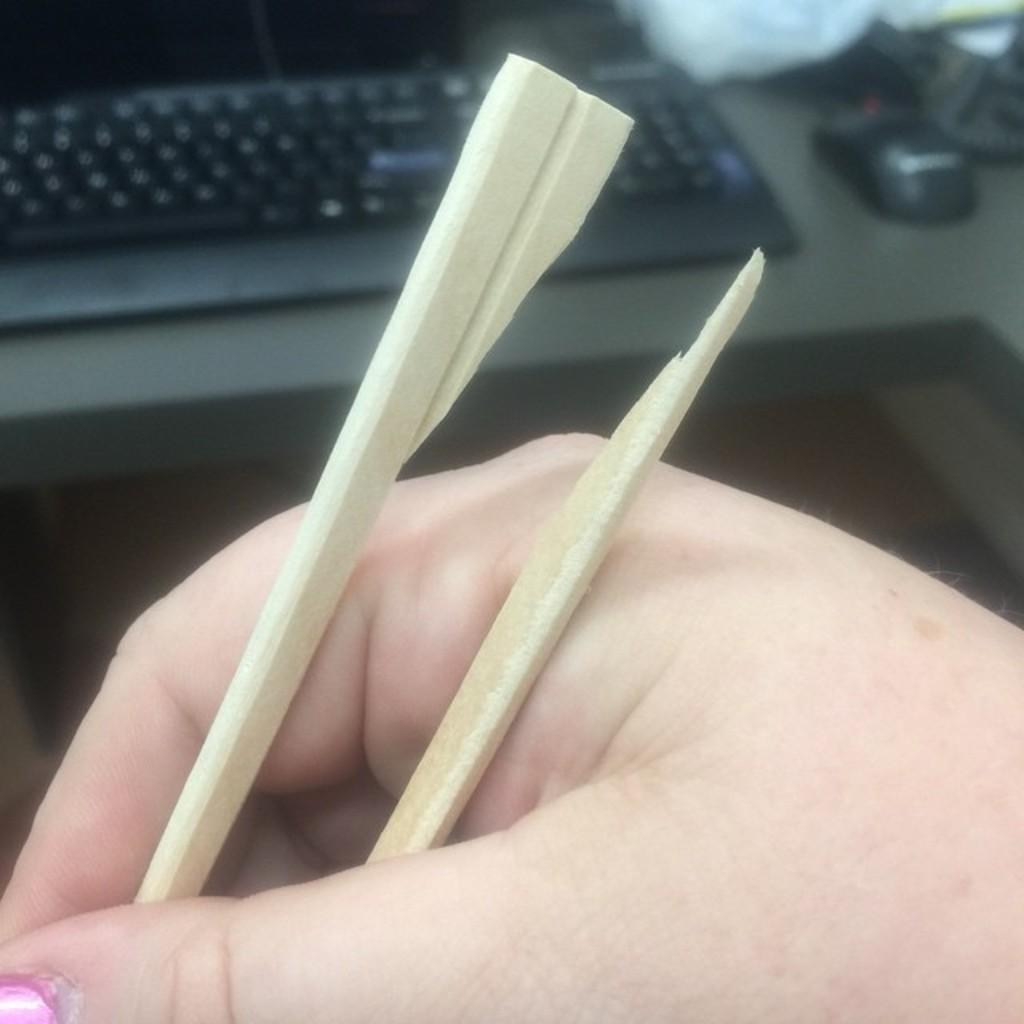Please provide a concise description of this image. In Front portion of the picture we can see a human´s hand holding a slate pencil. Here on the disk we can see a keyboard and a mouse. 